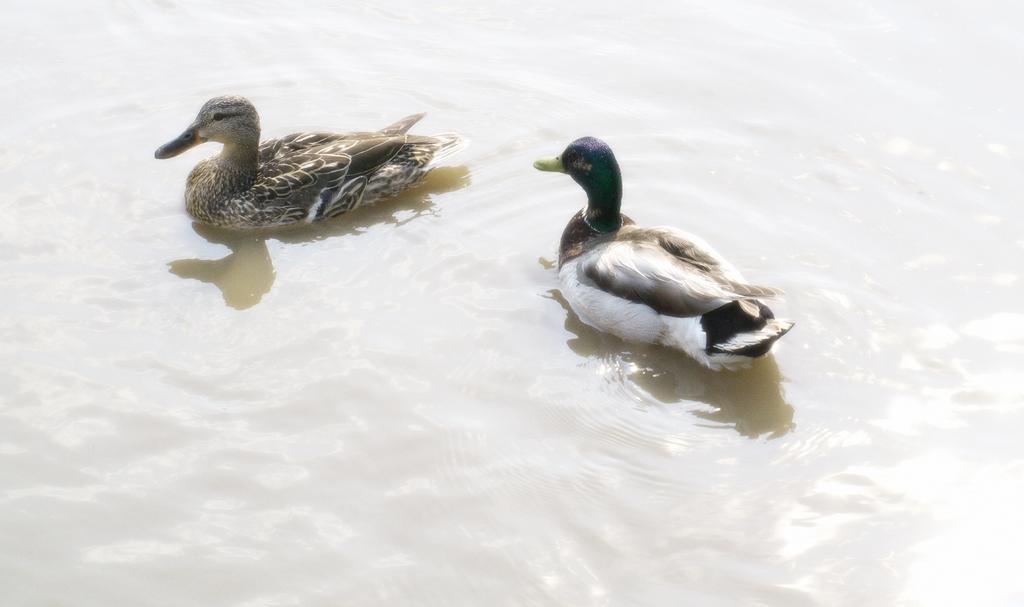How would you summarize this image in a sentence or two? In this image we can see ducks on the water. 